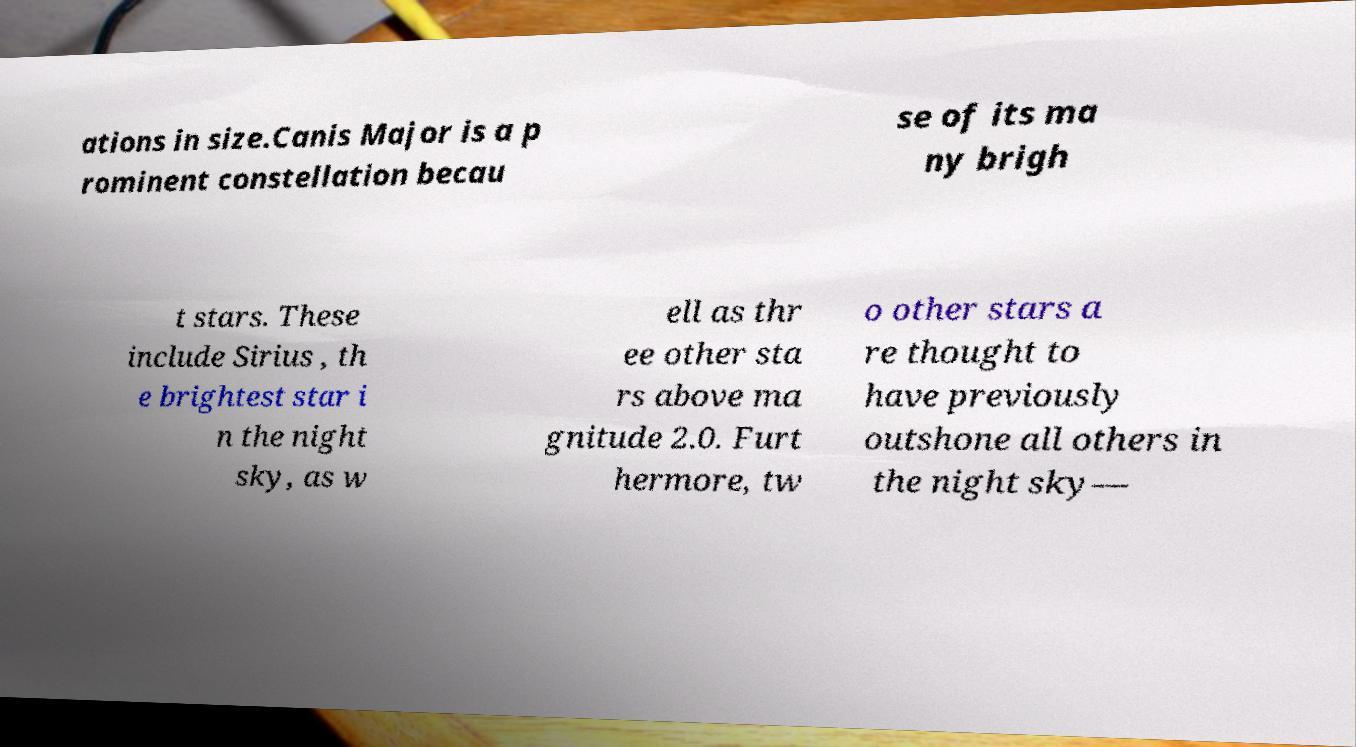Please identify and transcribe the text found in this image. ations in size.Canis Major is a p rominent constellation becau se of its ma ny brigh t stars. These include Sirius , th e brightest star i n the night sky, as w ell as thr ee other sta rs above ma gnitude 2.0. Furt hermore, tw o other stars a re thought to have previously outshone all others in the night sky— 